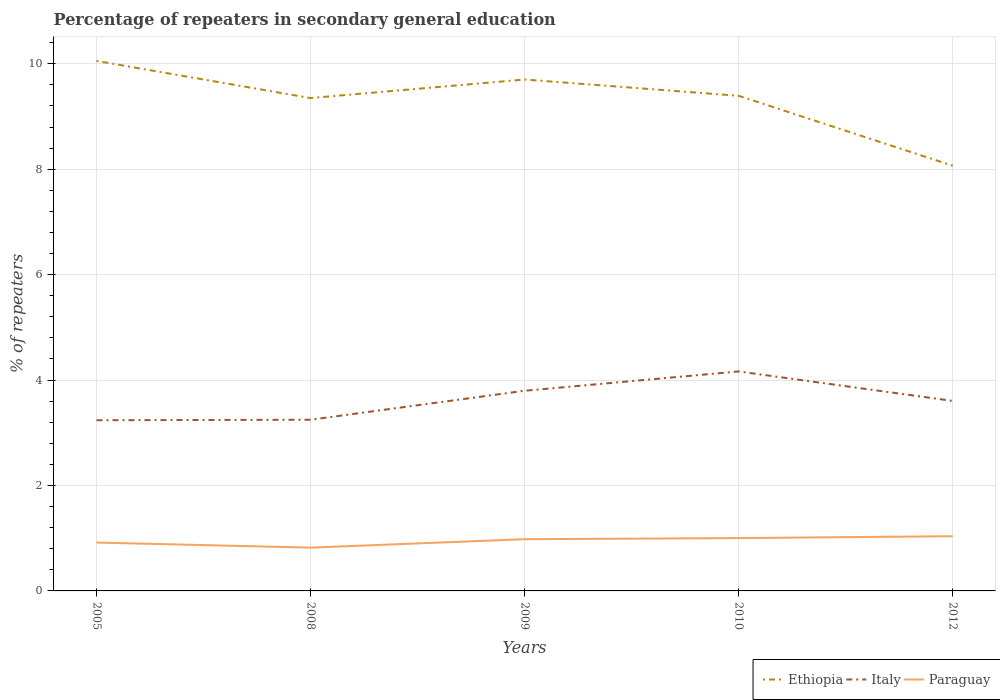How many different coloured lines are there?
Your response must be concise. 3. Does the line corresponding to Paraguay intersect with the line corresponding to Italy?
Provide a short and direct response. No. Is the number of lines equal to the number of legend labels?
Your answer should be very brief. Yes. Across all years, what is the maximum percentage of repeaters in secondary general education in Paraguay?
Give a very brief answer. 0.82. In which year was the percentage of repeaters in secondary general education in Ethiopia maximum?
Make the answer very short. 2012. What is the total percentage of repeaters in secondary general education in Italy in the graph?
Your response must be concise. -0.93. What is the difference between the highest and the second highest percentage of repeaters in secondary general education in Ethiopia?
Offer a terse response. 1.99. How many years are there in the graph?
Provide a succinct answer. 5. What is the difference between two consecutive major ticks on the Y-axis?
Give a very brief answer. 2. Are the values on the major ticks of Y-axis written in scientific E-notation?
Offer a very short reply. No. Does the graph contain any zero values?
Your answer should be very brief. No. How many legend labels are there?
Offer a very short reply. 3. How are the legend labels stacked?
Your answer should be very brief. Horizontal. What is the title of the graph?
Your answer should be compact. Percentage of repeaters in secondary general education. What is the label or title of the Y-axis?
Ensure brevity in your answer.  % of repeaters. What is the % of repeaters of Ethiopia in 2005?
Your response must be concise. 10.05. What is the % of repeaters in Italy in 2005?
Ensure brevity in your answer.  3.24. What is the % of repeaters in Paraguay in 2005?
Provide a succinct answer. 0.92. What is the % of repeaters of Ethiopia in 2008?
Provide a succinct answer. 9.35. What is the % of repeaters in Italy in 2008?
Your answer should be very brief. 3.25. What is the % of repeaters in Paraguay in 2008?
Keep it short and to the point. 0.82. What is the % of repeaters in Ethiopia in 2009?
Offer a terse response. 9.7. What is the % of repeaters in Italy in 2009?
Give a very brief answer. 3.8. What is the % of repeaters of Paraguay in 2009?
Offer a very short reply. 0.98. What is the % of repeaters of Ethiopia in 2010?
Your answer should be very brief. 9.39. What is the % of repeaters of Italy in 2010?
Your response must be concise. 4.16. What is the % of repeaters of Paraguay in 2010?
Your response must be concise. 1. What is the % of repeaters in Ethiopia in 2012?
Offer a very short reply. 8.07. What is the % of repeaters in Italy in 2012?
Give a very brief answer. 3.6. What is the % of repeaters of Paraguay in 2012?
Offer a terse response. 1.04. Across all years, what is the maximum % of repeaters of Ethiopia?
Your answer should be very brief. 10.05. Across all years, what is the maximum % of repeaters of Italy?
Keep it short and to the point. 4.16. Across all years, what is the maximum % of repeaters in Paraguay?
Offer a terse response. 1.04. Across all years, what is the minimum % of repeaters in Ethiopia?
Ensure brevity in your answer.  8.07. Across all years, what is the minimum % of repeaters of Italy?
Offer a terse response. 3.24. Across all years, what is the minimum % of repeaters in Paraguay?
Ensure brevity in your answer.  0.82. What is the total % of repeaters of Ethiopia in the graph?
Provide a short and direct response. 46.56. What is the total % of repeaters of Italy in the graph?
Give a very brief answer. 18.05. What is the total % of repeaters of Paraguay in the graph?
Offer a very short reply. 4.76. What is the difference between the % of repeaters of Ethiopia in 2005 and that in 2008?
Make the answer very short. 0.7. What is the difference between the % of repeaters of Italy in 2005 and that in 2008?
Offer a terse response. -0.01. What is the difference between the % of repeaters in Paraguay in 2005 and that in 2008?
Give a very brief answer. 0.1. What is the difference between the % of repeaters in Ethiopia in 2005 and that in 2009?
Your answer should be very brief. 0.35. What is the difference between the % of repeaters in Italy in 2005 and that in 2009?
Your answer should be compact. -0.56. What is the difference between the % of repeaters of Paraguay in 2005 and that in 2009?
Offer a terse response. -0.06. What is the difference between the % of repeaters in Ethiopia in 2005 and that in 2010?
Your answer should be very brief. 0.66. What is the difference between the % of repeaters of Italy in 2005 and that in 2010?
Offer a terse response. -0.93. What is the difference between the % of repeaters of Paraguay in 2005 and that in 2010?
Provide a succinct answer. -0.08. What is the difference between the % of repeaters of Ethiopia in 2005 and that in 2012?
Give a very brief answer. 1.99. What is the difference between the % of repeaters in Italy in 2005 and that in 2012?
Give a very brief answer. -0.37. What is the difference between the % of repeaters of Paraguay in 2005 and that in 2012?
Make the answer very short. -0.12. What is the difference between the % of repeaters of Ethiopia in 2008 and that in 2009?
Ensure brevity in your answer.  -0.35. What is the difference between the % of repeaters of Italy in 2008 and that in 2009?
Ensure brevity in your answer.  -0.55. What is the difference between the % of repeaters of Paraguay in 2008 and that in 2009?
Your answer should be very brief. -0.16. What is the difference between the % of repeaters in Ethiopia in 2008 and that in 2010?
Ensure brevity in your answer.  -0.04. What is the difference between the % of repeaters of Italy in 2008 and that in 2010?
Give a very brief answer. -0.92. What is the difference between the % of repeaters in Paraguay in 2008 and that in 2010?
Give a very brief answer. -0.18. What is the difference between the % of repeaters in Ethiopia in 2008 and that in 2012?
Make the answer very short. 1.28. What is the difference between the % of repeaters of Italy in 2008 and that in 2012?
Provide a succinct answer. -0.36. What is the difference between the % of repeaters in Paraguay in 2008 and that in 2012?
Keep it short and to the point. -0.22. What is the difference between the % of repeaters of Ethiopia in 2009 and that in 2010?
Your answer should be compact. 0.31. What is the difference between the % of repeaters in Italy in 2009 and that in 2010?
Offer a terse response. -0.37. What is the difference between the % of repeaters of Paraguay in 2009 and that in 2010?
Keep it short and to the point. -0.02. What is the difference between the % of repeaters of Ethiopia in 2009 and that in 2012?
Your answer should be very brief. 1.63. What is the difference between the % of repeaters of Italy in 2009 and that in 2012?
Offer a terse response. 0.19. What is the difference between the % of repeaters in Paraguay in 2009 and that in 2012?
Your response must be concise. -0.06. What is the difference between the % of repeaters in Ethiopia in 2010 and that in 2012?
Provide a short and direct response. 1.33. What is the difference between the % of repeaters of Italy in 2010 and that in 2012?
Keep it short and to the point. 0.56. What is the difference between the % of repeaters of Paraguay in 2010 and that in 2012?
Your answer should be compact. -0.04. What is the difference between the % of repeaters in Ethiopia in 2005 and the % of repeaters in Italy in 2008?
Your response must be concise. 6.81. What is the difference between the % of repeaters of Ethiopia in 2005 and the % of repeaters of Paraguay in 2008?
Offer a very short reply. 9.23. What is the difference between the % of repeaters of Italy in 2005 and the % of repeaters of Paraguay in 2008?
Offer a terse response. 2.42. What is the difference between the % of repeaters in Ethiopia in 2005 and the % of repeaters in Italy in 2009?
Keep it short and to the point. 6.26. What is the difference between the % of repeaters in Ethiopia in 2005 and the % of repeaters in Paraguay in 2009?
Provide a short and direct response. 9.07. What is the difference between the % of repeaters in Italy in 2005 and the % of repeaters in Paraguay in 2009?
Keep it short and to the point. 2.26. What is the difference between the % of repeaters in Ethiopia in 2005 and the % of repeaters in Italy in 2010?
Ensure brevity in your answer.  5.89. What is the difference between the % of repeaters of Ethiopia in 2005 and the % of repeaters of Paraguay in 2010?
Offer a very short reply. 9.05. What is the difference between the % of repeaters of Italy in 2005 and the % of repeaters of Paraguay in 2010?
Your answer should be very brief. 2.24. What is the difference between the % of repeaters in Ethiopia in 2005 and the % of repeaters in Italy in 2012?
Keep it short and to the point. 6.45. What is the difference between the % of repeaters in Ethiopia in 2005 and the % of repeaters in Paraguay in 2012?
Offer a very short reply. 9.02. What is the difference between the % of repeaters of Italy in 2005 and the % of repeaters of Paraguay in 2012?
Your answer should be very brief. 2.2. What is the difference between the % of repeaters in Ethiopia in 2008 and the % of repeaters in Italy in 2009?
Keep it short and to the point. 5.55. What is the difference between the % of repeaters of Ethiopia in 2008 and the % of repeaters of Paraguay in 2009?
Offer a very short reply. 8.37. What is the difference between the % of repeaters of Italy in 2008 and the % of repeaters of Paraguay in 2009?
Make the answer very short. 2.27. What is the difference between the % of repeaters of Ethiopia in 2008 and the % of repeaters of Italy in 2010?
Your answer should be very brief. 5.19. What is the difference between the % of repeaters of Ethiopia in 2008 and the % of repeaters of Paraguay in 2010?
Ensure brevity in your answer.  8.35. What is the difference between the % of repeaters of Italy in 2008 and the % of repeaters of Paraguay in 2010?
Give a very brief answer. 2.25. What is the difference between the % of repeaters in Ethiopia in 2008 and the % of repeaters in Italy in 2012?
Your response must be concise. 5.75. What is the difference between the % of repeaters in Ethiopia in 2008 and the % of repeaters in Paraguay in 2012?
Provide a short and direct response. 8.31. What is the difference between the % of repeaters in Italy in 2008 and the % of repeaters in Paraguay in 2012?
Offer a terse response. 2.21. What is the difference between the % of repeaters in Ethiopia in 2009 and the % of repeaters in Italy in 2010?
Make the answer very short. 5.54. What is the difference between the % of repeaters of Ethiopia in 2009 and the % of repeaters of Paraguay in 2010?
Give a very brief answer. 8.7. What is the difference between the % of repeaters of Italy in 2009 and the % of repeaters of Paraguay in 2010?
Give a very brief answer. 2.8. What is the difference between the % of repeaters in Ethiopia in 2009 and the % of repeaters in Italy in 2012?
Offer a terse response. 6.1. What is the difference between the % of repeaters of Ethiopia in 2009 and the % of repeaters of Paraguay in 2012?
Give a very brief answer. 8.66. What is the difference between the % of repeaters of Italy in 2009 and the % of repeaters of Paraguay in 2012?
Ensure brevity in your answer.  2.76. What is the difference between the % of repeaters in Ethiopia in 2010 and the % of repeaters in Italy in 2012?
Your answer should be very brief. 5.79. What is the difference between the % of repeaters of Ethiopia in 2010 and the % of repeaters of Paraguay in 2012?
Make the answer very short. 8.35. What is the difference between the % of repeaters in Italy in 2010 and the % of repeaters in Paraguay in 2012?
Provide a succinct answer. 3.13. What is the average % of repeaters of Ethiopia per year?
Your answer should be very brief. 9.31. What is the average % of repeaters of Italy per year?
Your answer should be compact. 3.61. What is the average % of repeaters of Paraguay per year?
Offer a very short reply. 0.95. In the year 2005, what is the difference between the % of repeaters in Ethiopia and % of repeaters in Italy?
Provide a succinct answer. 6.82. In the year 2005, what is the difference between the % of repeaters in Ethiopia and % of repeaters in Paraguay?
Offer a terse response. 9.14. In the year 2005, what is the difference between the % of repeaters of Italy and % of repeaters of Paraguay?
Provide a short and direct response. 2.32. In the year 2008, what is the difference between the % of repeaters in Ethiopia and % of repeaters in Italy?
Make the answer very short. 6.1. In the year 2008, what is the difference between the % of repeaters in Ethiopia and % of repeaters in Paraguay?
Give a very brief answer. 8.53. In the year 2008, what is the difference between the % of repeaters in Italy and % of repeaters in Paraguay?
Offer a terse response. 2.43. In the year 2009, what is the difference between the % of repeaters in Ethiopia and % of repeaters in Italy?
Provide a short and direct response. 5.9. In the year 2009, what is the difference between the % of repeaters in Ethiopia and % of repeaters in Paraguay?
Offer a terse response. 8.72. In the year 2009, what is the difference between the % of repeaters of Italy and % of repeaters of Paraguay?
Offer a terse response. 2.82. In the year 2010, what is the difference between the % of repeaters of Ethiopia and % of repeaters of Italy?
Provide a short and direct response. 5.23. In the year 2010, what is the difference between the % of repeaters in Ethiopia and % of repeaters in Paraguay?
Give a very brief answer. 8.39. In the year 2010, what is the difference between the % of repeaters in Italy and % of repeaters in Paraguay?
Ensure brevity in your answer.  3.16. In the year 2012, what is the difference between the % of repeaters in Ethiopia and % of repeaters in Italy?
Your response must be concise. 4.46. In the year 2012, what is the difference between the % of repeaters of Ethiopia and % of repeaters of Paraguay?
Your answer should be very brief. 7.03. In the year 2012, what is the difference between the % of repeaters of Italy and % of repeaters of Paraguay?
Give a very brief answer. 2.57. What is the ratio of the % of repeaters in Ethiopia in 2005 to that in 2008?
Your response must be concise. 1.08. What is the ratio of the % of repeaters of Paraguay in 2005 to that in 2008?
Your answer should be compact. 1.12. What is the ratio of the % of repeaters in Ethiopia in 2005 to that in 2009?
Your response must be concise. 1.04. What is the ratio of the % of repeaters of Italy in 2005 to that in 2009?
Offer a very short reply. 0.85. What is the ratio of the % of repeaters of Paraguay in 2005 to that in 2009?
Provide a short and direct response. 0.94. What is the ratio of the % of repeaters of Ethiopia in 2005 to that in 2010?
Offer a terse response. 1.07. What is the ratio of the % of repeaters in Italy in 2005 to that in 2010?
Ensure brevity in your answer.  0.78. What is the ratio of the % of repeaters of Paraguay in 2005 to that in 2010?
Ensure brevity in your answer.  0.92. What is the ratio of the % of repeaters of Ethiopia in 2005 to that in 2012?
Offer a terse response. 1.25. What is the ratio of the % of repeaters of Italy in 2005 to that in 2012?
Ensure brevity in your answer.  0.9. What is the ratio of the % of repeaters of Paraguay in 2005 to that in 2012?
Keep it short and to the point. 0.88. What is the ratio of the % of repeaters in Ethiopia in 2008 to that in 2009?
Your answer should be very brief. 0.96. What is the ratio of the % of repeaters of Italy in 2008 to that in 2009?
Provide a short and direct response. 0.86. What is the ratio of the % of repeaters of Paraguay in 2008 to that in 2009?
Offer a terse response. 0.84. What is the ratio of the % of repeaters of Italy in 2008 to that in 2010?
Offer a very short reply. 0.78. What is the ratio of the % of repeaters in Paraguay in 2008 to that in 2010?
Offer a very short reply. 0.82. What is the ratio of the % of repeaters of Ethiopia in 2008 to that in 2012?
Your answer should be compact. 1.16. What is the ratio of the % of repeaters of Italy in 2008 to that in 2012?
Provide a short and direct response. 0.9. What is the ratio of the % of repeaters in Paraguay in 2008 to that in 2012?
Offer a terse response. 0.79. What is the ratio of the % of repeaters of Ethiopia in 2009 to that in 2010?
Give a very brief answer. 1.03. What is the ratio of the % of repeaters of Italy in 2009 to that in 2010?
Ensure brevity in your answer.  0.91. What is the ratio of the % of repeaters in Paraguay in 2009 to that in 2010?
Provide a succinct answer. 0.98. What is the ratio of the % of repeaters in Ethiopia in 2009 to that in 2012?
Your response must be concise. 1.2. What is the ratio of the % of repeaters of Italy in 2009 to that in 2012?
Offer a terse response. 1.05. What is the ratio of the % of repeaters in Paraguay in 2009 to that in 2012?
Your response must be concise. 0.95. What is the ratio of the % of repeaters of Ethiopia in 2010 to that in 2012?
Keep it short and to the point. 1.16. What is the ratio of the % of repeaters of Italy in 2010 to that in 2012?
Your answer should be very brief. 1.16. What is the ratio of the % of repeaters of Paraguay in 2010 to that in 2012?
Make the answer very short. 0.97. What is the difference between the highest and the second highest % of repeaters of Ethiopia?
Offer a terse response. 0.35. What is the difference between the highest and the second highest % of repeaters of Italy?
Ensure brevity in your answer.  0.37. What is the difference between the highest and the second highest % of repeaters in Paraguay?
Give a very brief answer. 0.04. What is the difference between the highest and the lowest % of repeaters in Ethiopia?
Offer a very short reply. 1.99. What is the difference between the highest and the lowest % of repeaters of Italy?
Provide a short and direct response. 0.93. What is the difference between the highest and the lowest % of repeaters in Paraguay?
Provide a succinct answer. 0.22. 